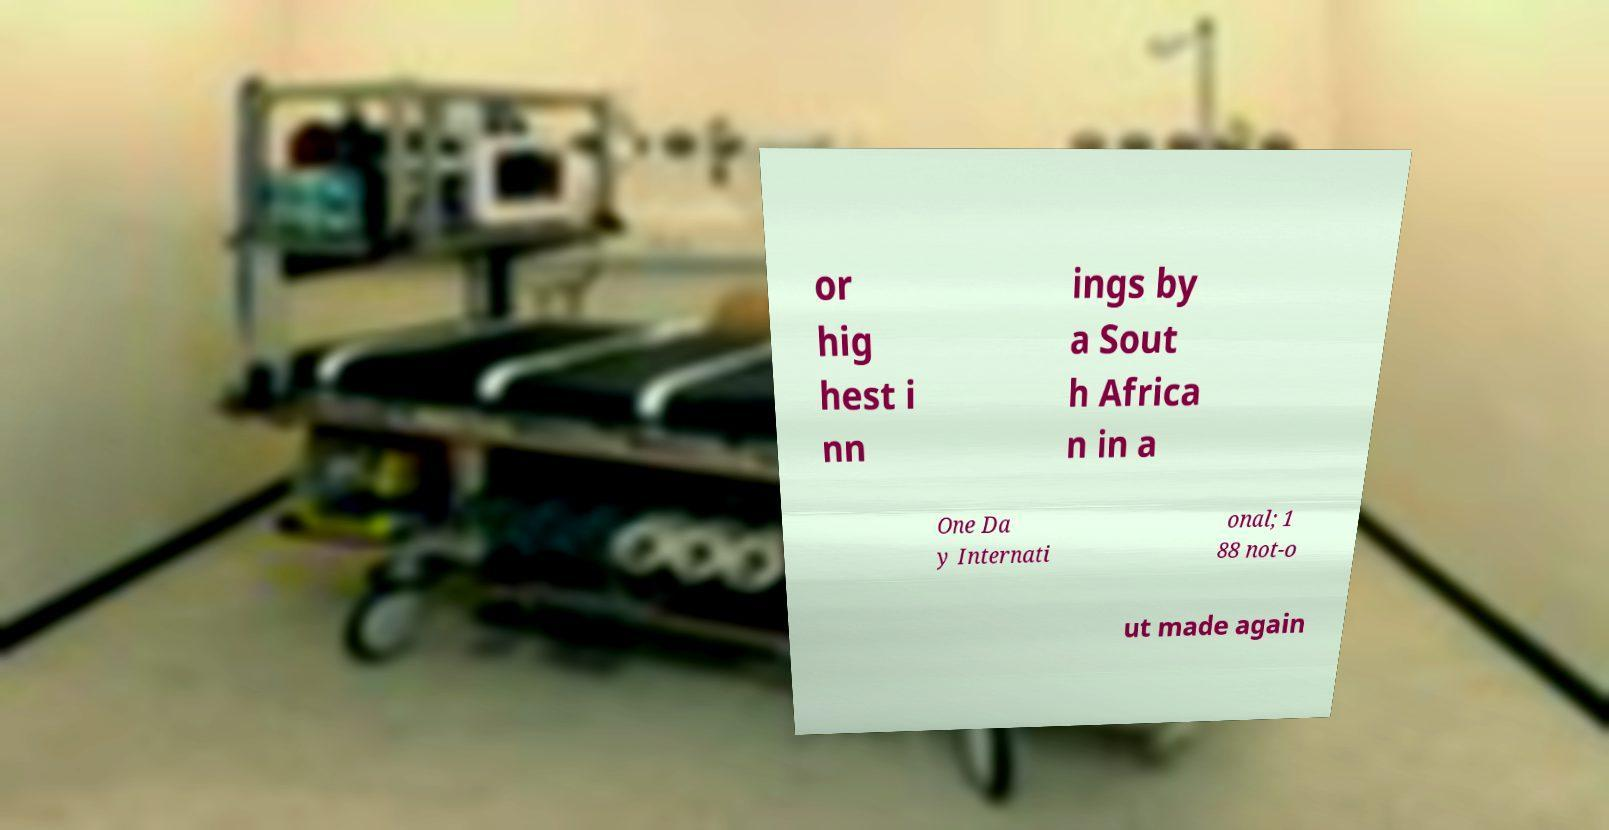What messages or text are displayed in this image? I need them in a readable, typed format. or hig hest i nn ings by a Sout h Africa n in a One Da y Internati onal; 1 88 not-o ut made again 